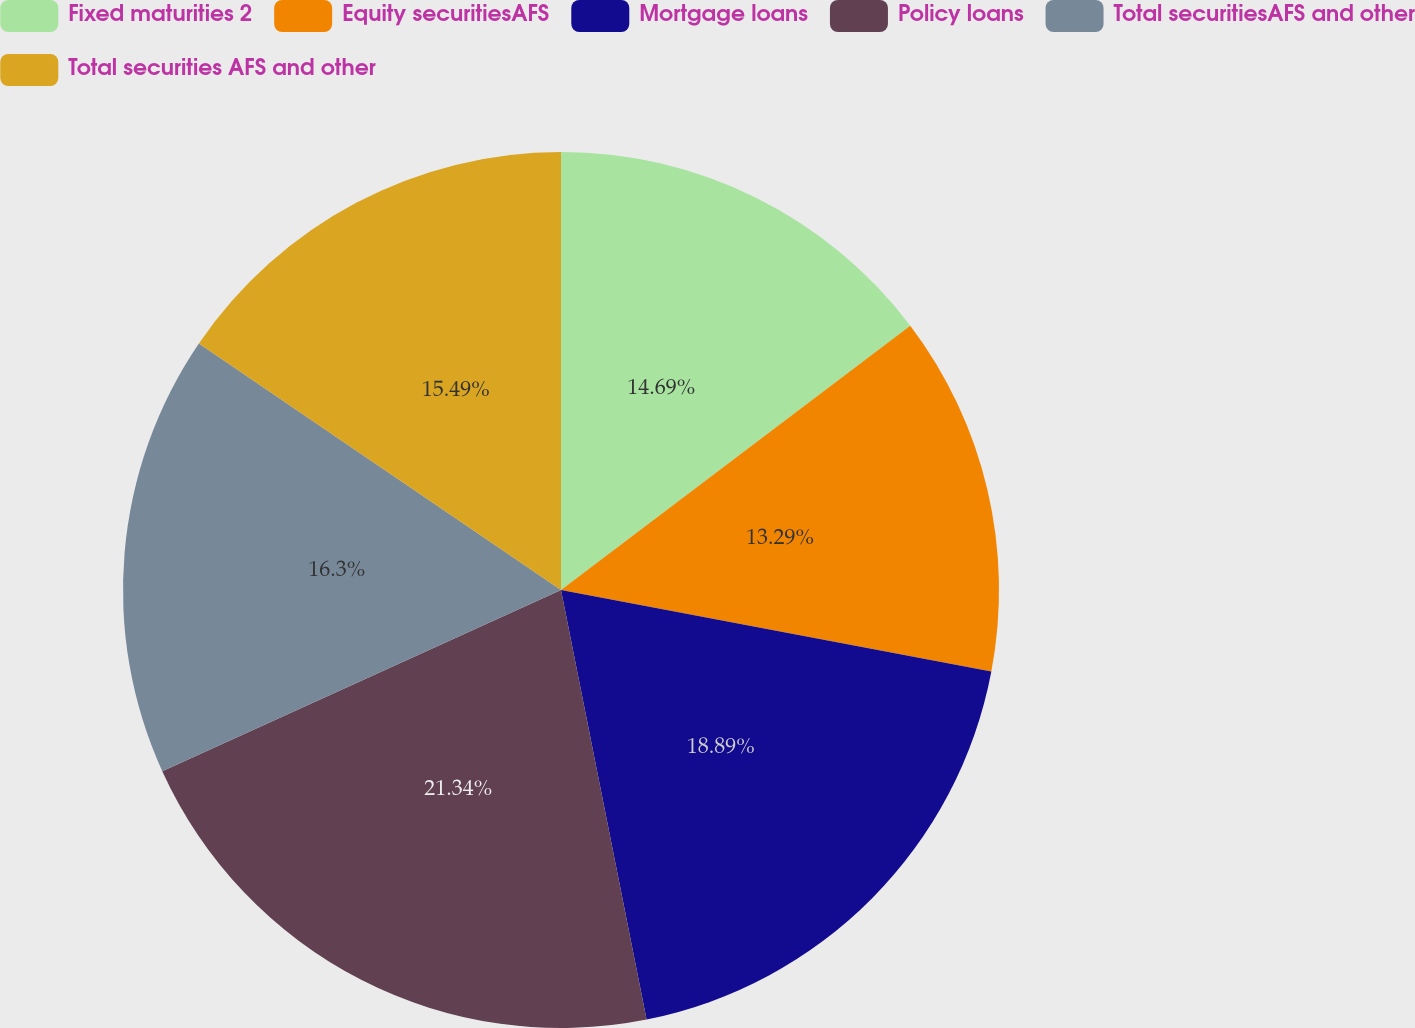Convert chart. <chart><loc_0><loc_0><loc_500><loc_500><pie_chart><fcel>Fixed maturities 2<fcel>Equity securitiesAFS<fcel>Mortgage loans<fcel>Policy loans<fcel>Total securitiesAFS and other<fcel>Total securities AFS and other<nl><fcel>14.69%<fcel>13.29%<fcel>18.89%<fcel>21.34%<fcel>16.3%<fcel>15.49%<nl></chart> 